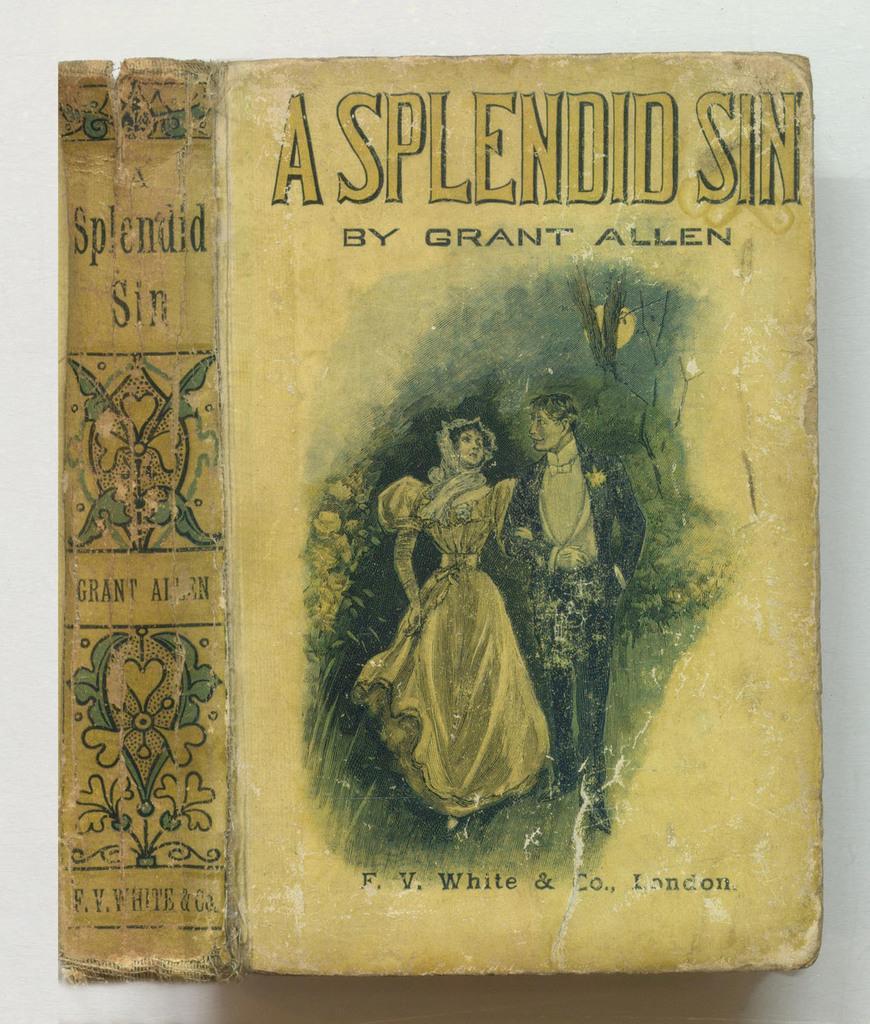<image>
Write a terse but informative summary of the picture. An antique book titled "A Splendid Sin" by Grant Allen. 